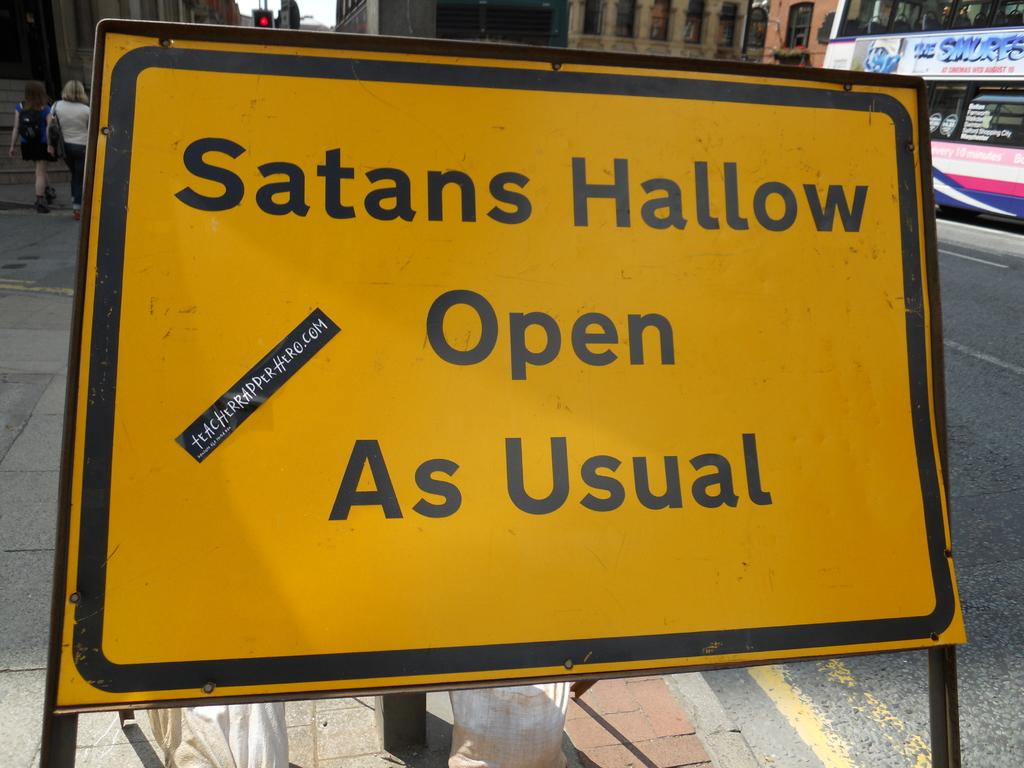What does that sign say?
Keep it short and to the point. Satans hallow open as usual. Which little blue characters are being advertised on the top right?
Provide a short and direct response. The smurfs. 